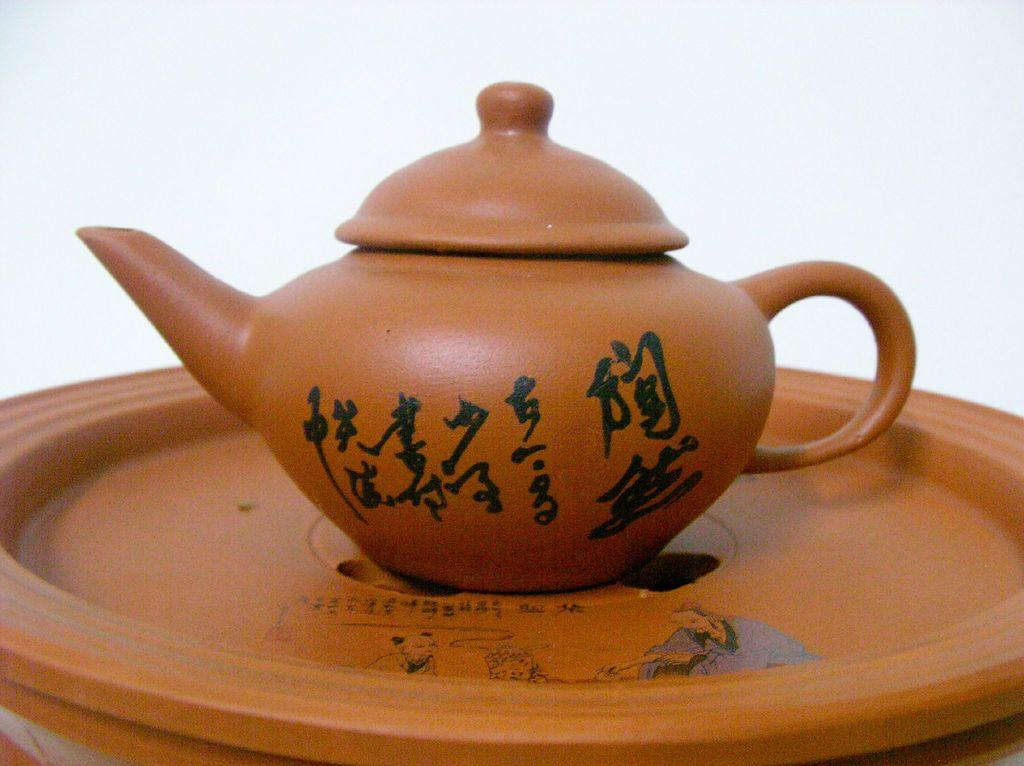What is the main object in the image? There is a teapot in the image. How is the teapot positioned in the image? The teapot is placed on a plate. What is unique about the plate? The plate has a painting on it. What type of vessel is the goldfish swimming in during the meeting in the image? There is no vessel or meeting present in the image, and therefore no such activity can be observed. 